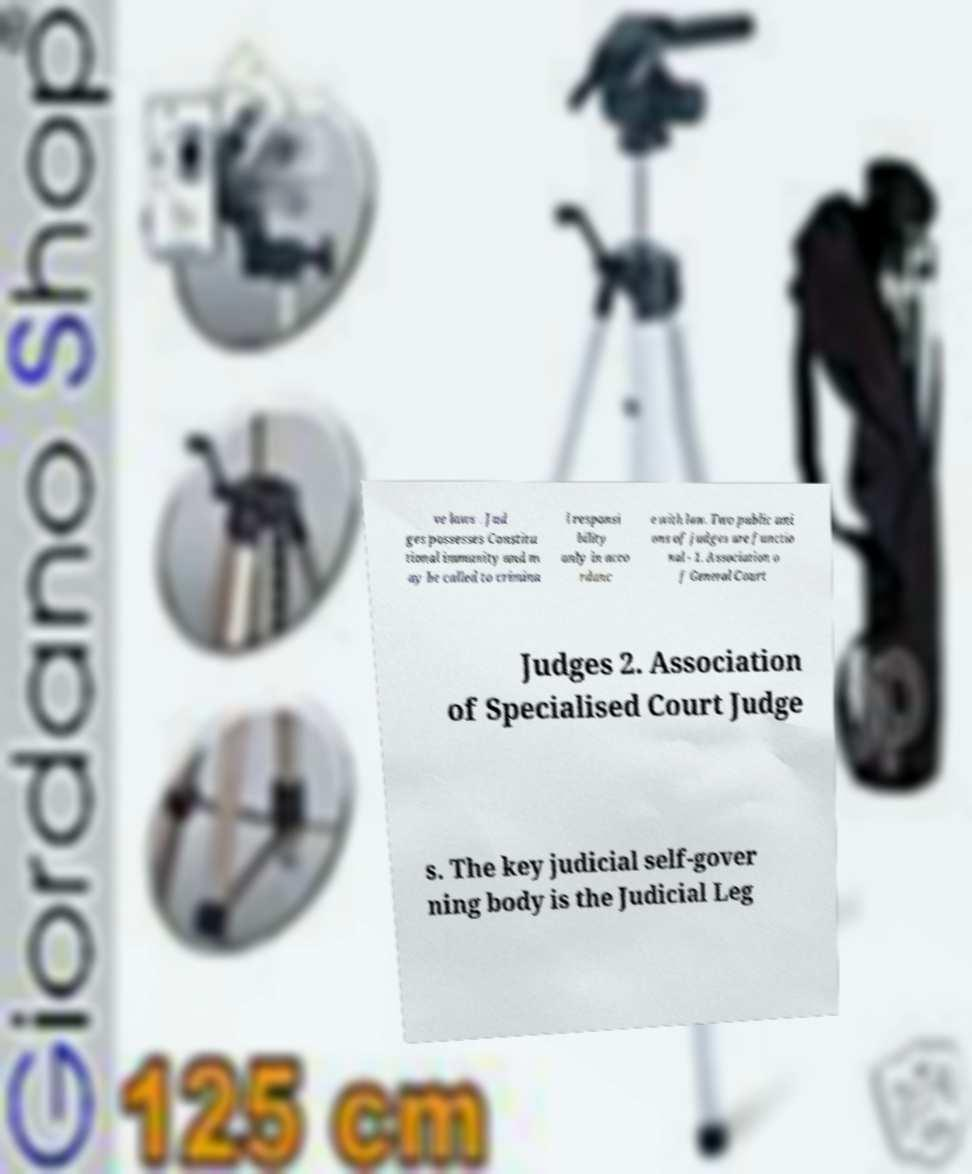Could you assist in decoding the text presented in this image and type it out clearly? ve laws . Jud ges possesses Constitu tional immunity and m ay be called to crimina l responsi bility only in acco rdanc e with law. Two public uni ons of judges are functio nal - 1. Association o f General Court Judges 2. Association of Specialised Court Judge s. The key judicial self-gover ning body is the Judicial Leg 